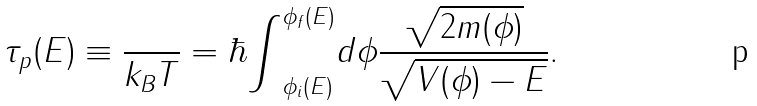Convert formula to latex. <formula><loc_0><loc_0><loc_500><loc_500>\tau _ { p } ( E ) \equiv \frac { } { k _ { B } T } = \hbar { \int } _ { \phi _ { i } ( E ) } ^ { \phi _ { f } ( E ) } d \phi \frac { \sqrt { 2 m ( \phi ) } } { \sqrt { V ( \phi ) - E } } .</formula> 